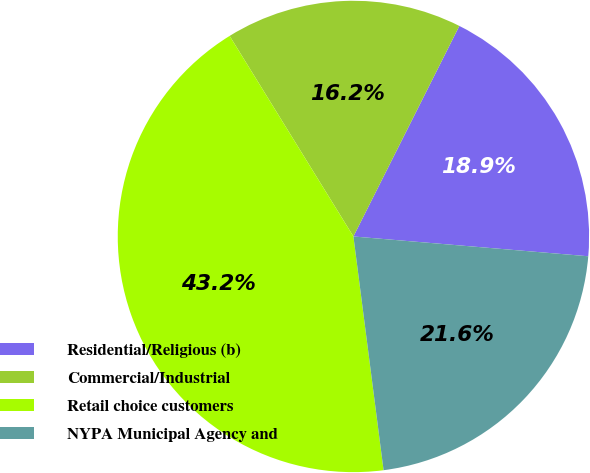<chart> <loc_0><loc_0><loc_500><loc_500><pie_chart><fcel>Residential/Religious (b)<fcel>Commercial/Industrial<fcel>Retail choice customers<fcel>NYPA Municipal Agency and<nl><fcel>18.92%<fcel>16.22%<fcel>43.24%<fcel>21.62%<nl></chart> 